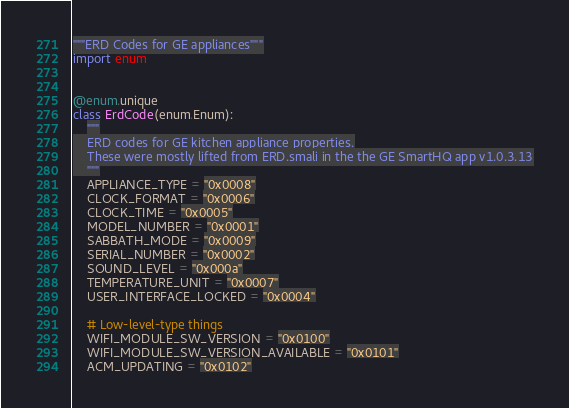Convert code to text. <code><loc_0><loc_0><loc_500><loc_500><_Python_>"""ERD Codes for GE appliances"""
import enum


@enum.unique
class ErdCode(enum.Enum):
    """
    ERD codes for GE kitchen appliance properties.
    These were mostly lifted from ERD.smali in the the GE SmartHQ app v1.0.3.13
    """
    APPLIANCE_TYPE = "0x0008"
    CLOCK_FORMAT = "0x0006"
    CLOCK_TIME = "0x0005"
    MODEL_NUMBER = "0x0001"
    SABBATH_MODE = "0x0009"
    SERIAL_NUMBER = "0x0002"
    SOUND_LEVEL = "0x000a"
    TEMPERATURE_UNIT = "0x0007"
    USER_INTERFACE_LOCKED = "0x0004"

    # Low-level-type things
    WIFI_MODULE_SW_VERSION = "0x0100"
    WIFI_MODULE_SW_VERSION_AVAILABLE = "0x0101"
    ACM_UPDATING = "0x0102"</code> 